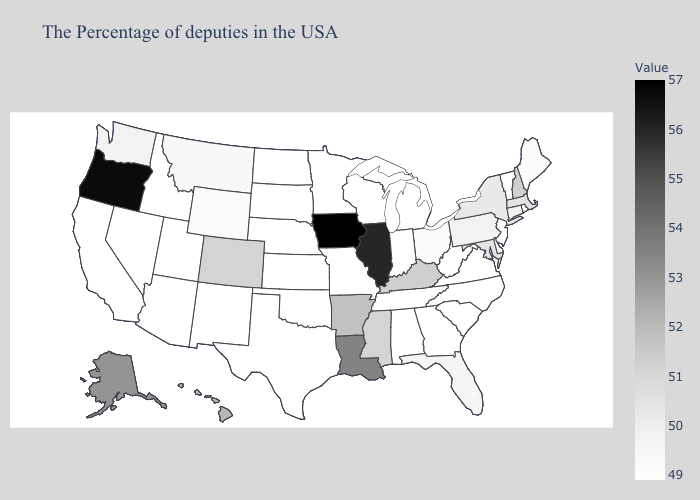Which states have the highest value in the USA?
Short answer required. Iowa. Which states have the lowest value in the South?
Be succinct. Virginia, North Carolina, South Carolina, West Virginia, Georgia, Alabama, Tennessee, Oklahoma, Texas. Among the states that border Georgia , which have the highest value?
Give a very brief answer. Florida. Does Vermont have the lowest value in the Northeast?
Keep it brief. Yes. Among the states that border Louisiana , does Arkansas have the lowest value?
Write a very short answer. No. Does Oregon have the lowest value in the USA?
Quick response, please. No. Does North Dakota have the lowest value in the USA?
Answer briefly. Yes. 